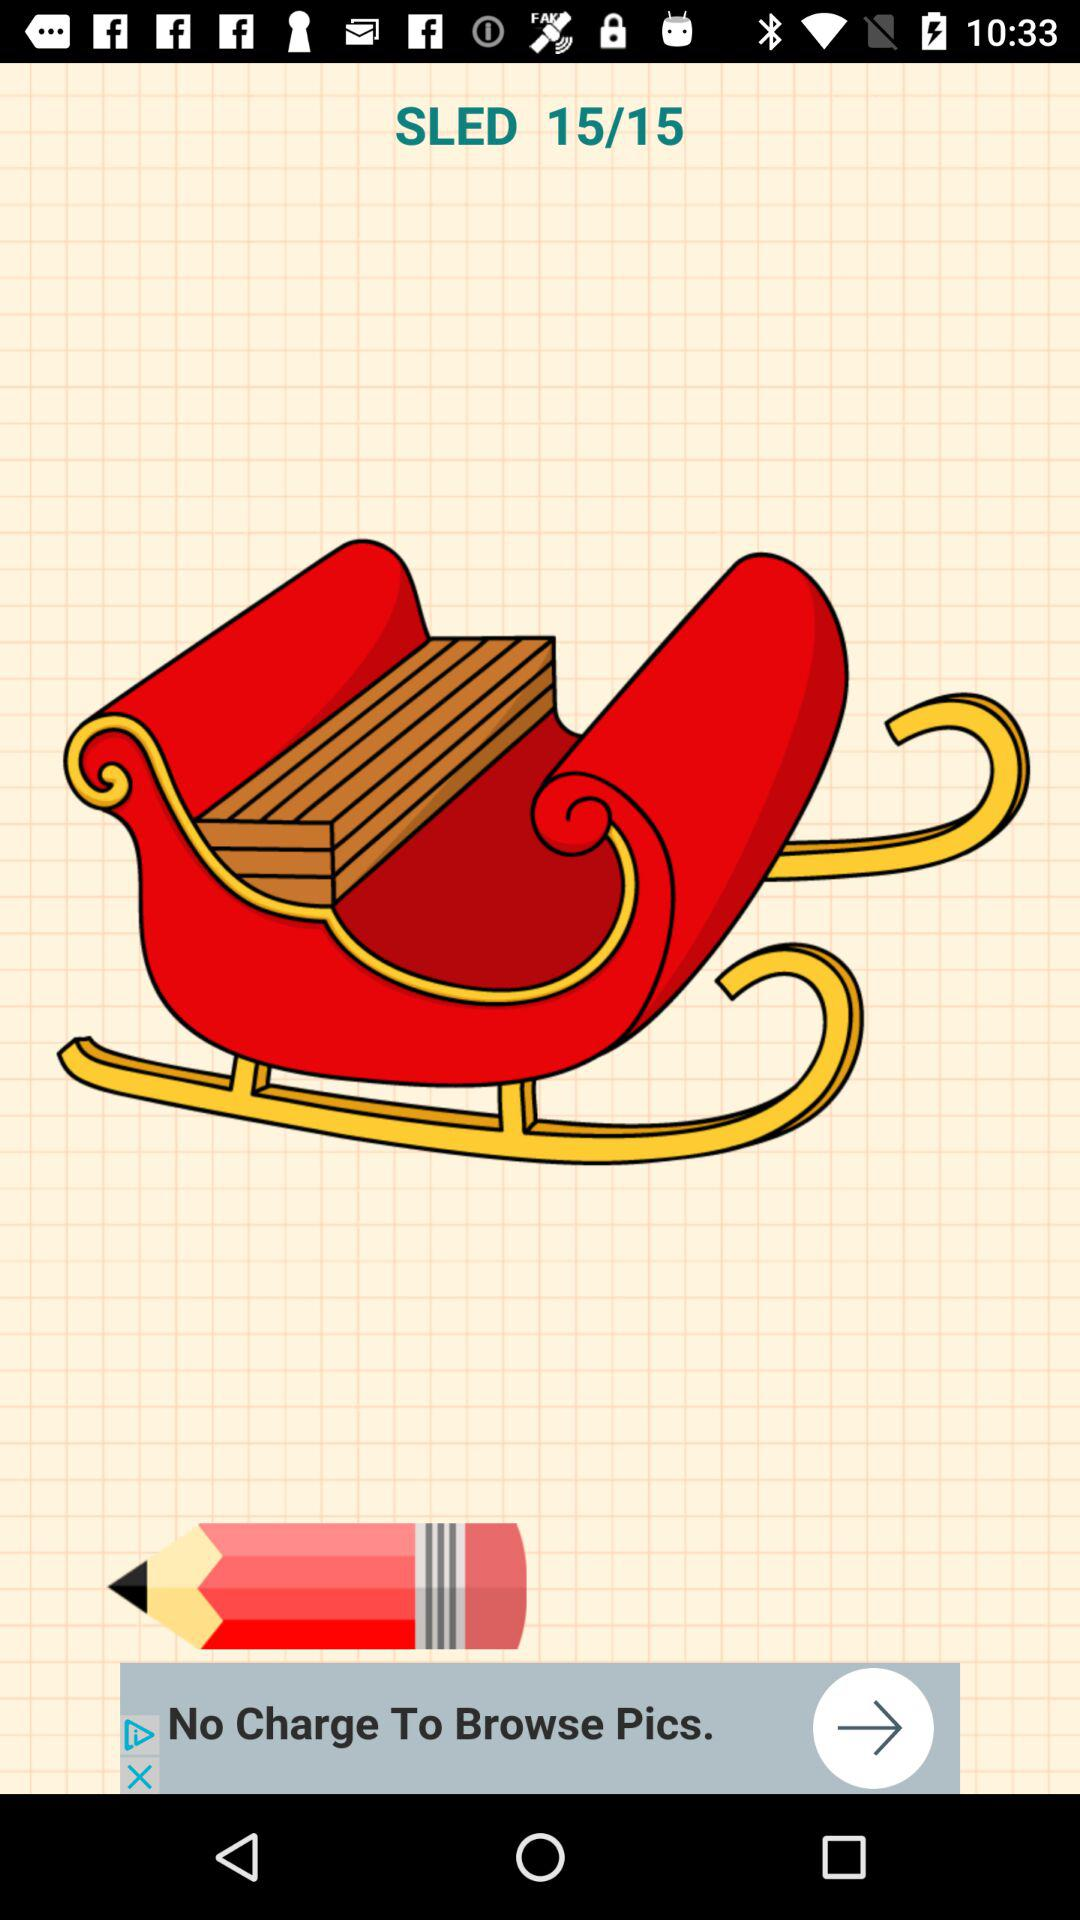What does image 14 show?
When the provided information is insufficient, respond with <no answer>. <no answer> 